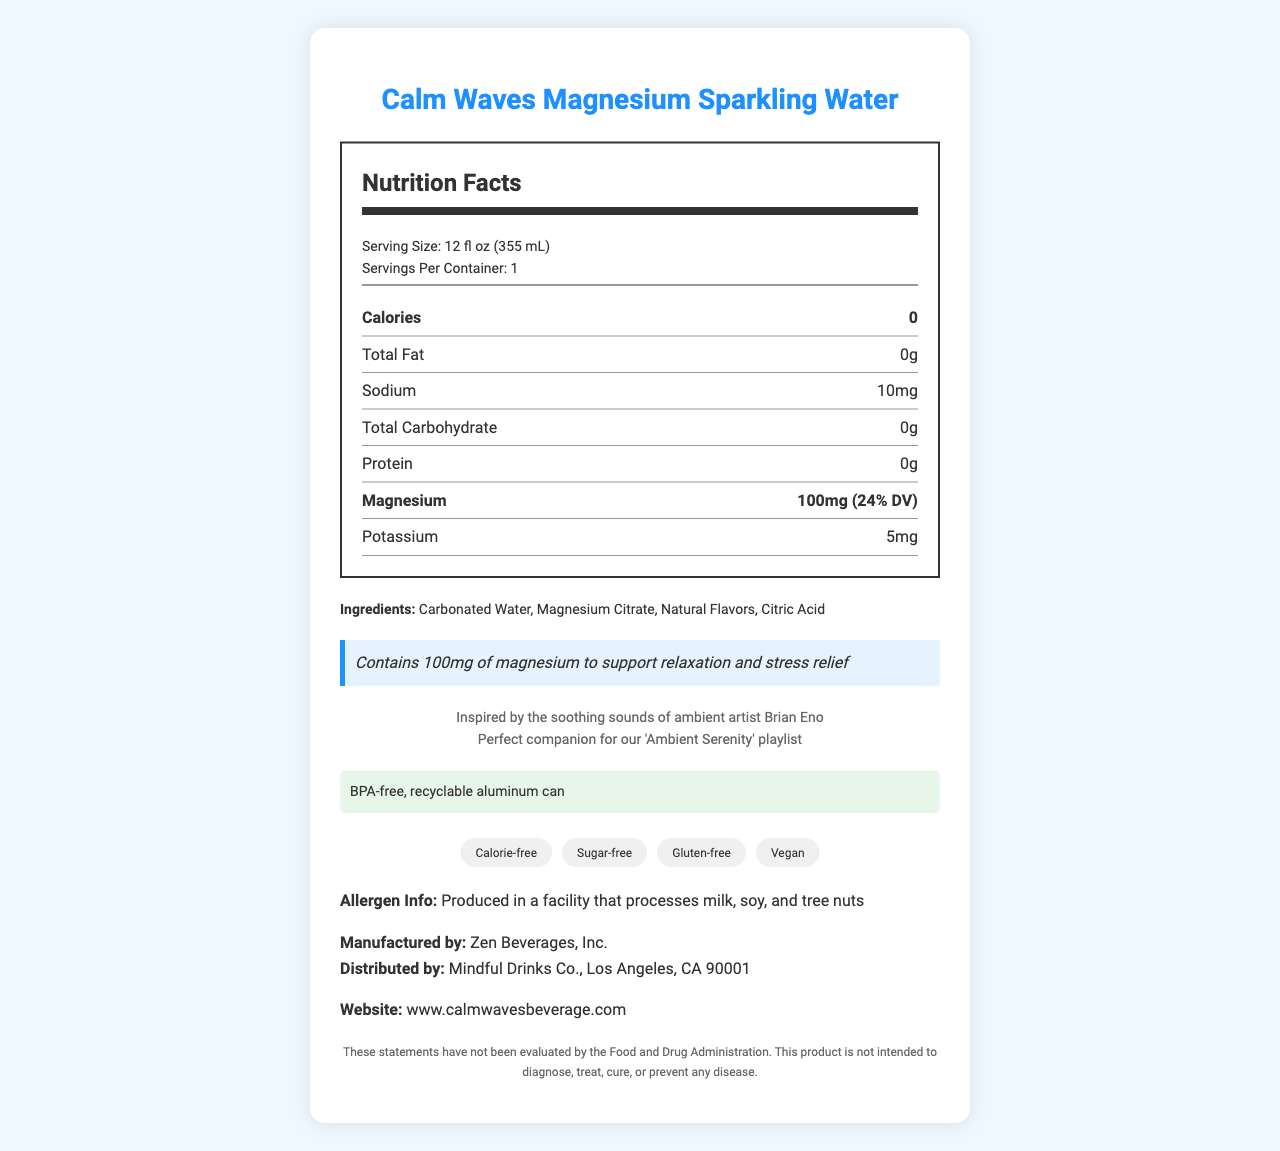what is the serving size of Calm Waves Magnesium Sparkling Water? The serving size is clearly mentioned as 12 fl oz (355 mL) under the serving information section.
Answer: 12 fl oz (355 mL) what is the amount of magnesium per serving? The document states that each serving contains 100mg of magnesium.
Answer: 100mg how many calories are in each serving of this beverage? The calories per serving are listed as 0 in the Nutrition Facts section.
Answer: 0 what type of facility is this product produced in? The allergen information mentions that the product is produced in a facility that processes milk, soy, and tree nuts.
Answer: A facility that processes milk, soy, and tree nuts which ingredient precedes "Natural Flavors" in the ingredient list? In the ingredient list, Magnesium Citrate comes before Natural Flavors.
Answer: Magnesium Citrate how are the beverages packaged? The environmental information mentions that the beverage comes in a BPA-free, recyclable aluminum can.
Answer: BPA-free, recyclable aluminum can which ambient artist inspired this product? A. Brian Eno B. Moby C. Aphex Twin D. Steve Roach The document highlights that the product is inspired by the soothing sounds of ambient artist Brian Eno.
Answer: A. Brian Eno what is the sodium content per serving? A. 0mg B. 5mg C. 10mg D. 15mg The sodium content per serving is listed as 10mg in the Nutrition Facts section.
Answer: C. 10mg is this product calorie-free? The dietary info explicitly states that the product is calorie-free.
Answer: Yes describe the main idea of this document. The main idea of the document revolves around the product's nutrition facts, ingredients, dietary information, relaxation benefits, and connection to ambient music, specifically highlighting its zero-calorie and vegan-friendly nature.
Answer: The document provides the Nutrition Facts and essential details of Calm Waves Magnesium Sparkling Water, a magnesium-fortified, calorie-free, and vegan sparkling water designed for relaxation and stress relief. It highlights the nutritional content, ingredients, and packaging information and mentions that the product is inspired by ambient artist Brian Eno. who is the manufacturer of Calm Waves Magnesium Sparkling Water? The manufacturer of the product is listed as Zen Beverages, Inc.
Answer: Zen Beverages, Inc. what is the percentage of the daily value of magnesium per serving? The magnesium content provides 24% of the daily value according to the Nutrition Facts section.
Answer: 24% does this product contain any iron? The Nutrition Facts section shows 0mg of iron per serving.
Answer: No what is the exact website URL provided for more information? The document provides the website URL as www.calmwavesbeverage.com.
Answer: www.calmwavesbeverage.com what is the product designed to alleviate? The relaxation claim states that the product contains magnesium to support relaxation and stress relief.
Answer: Relaxation and stress relief how many grams of protein are there per serving? The Nutrition Facts section shows 0 grams of protein per serving.
Answer: 0g which food allergens could potentially be found in this product? The document mentions that the product is produced in a facility that processes milk, soy, and tree nuts.
Answer: Milk, soy, and tree nuts how much vitamin C does this beverage contain per serving? The Nutrition Facts section shows 0mg of vitamin C per serving.
Answer: 0mg what flavors or sounds are associated with Calm Waves Magnesium Sparkling Water? The document doesn't provide specific details on the natural flavors or the exact sounds associated, only mentioning "Natural Flavors."
Answer: Not enough information what company distributes Calm Waves Magnesium Sparkling Water? A. Zen Beverages, Inc. B. Mindful Drinks Co. C. Vitamin Water Corp. The distributor is listed as Mindful Drinks Co., Los Angeles, CA 90001.
Answer: B. Mindful Drinks Co. 